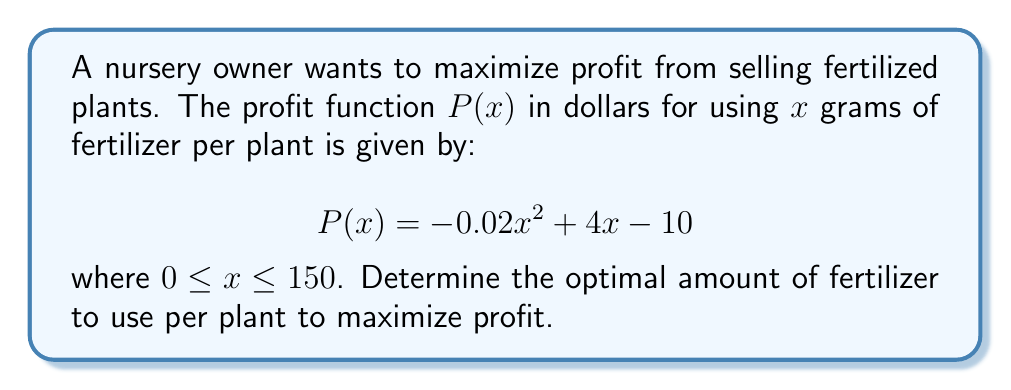What is the answer to this math problem? To find the optimal amount of fertilizer, we need to maximize the profit function $P(x)$. We can do this by finding the critical point where the derivative of $P(x)$ equals zero.

Step 1: Find the derivative of $P(x)$.
$$P'(x) = -0.04x + 4$$

Step 2: Set the derivative equal to zero and solve for x.
$$-0.04x + 4 = 0$$
$$-0.04x = -4$$
$$x = 100$$

Step 3: Verify that this critical point is a maximum by checking the second derivative.
$$P''(x) = -0.04$$
Since $P''(x)$ is negative, the critical point is a maximum.

Step 4: Check the endpoints of the interval $[0, 150]$.
$P(0) = -10$
$P(100) = 190$
$P(150) = 140$

The maximum profit occurs at $x = 100$, which is within the given interval.

Therefore, the optimal amount of fertilizer to use per plant is 100 grams.
Answer: 100 grams 